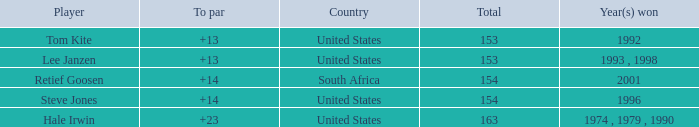In what year did the United States win To par greater than 14 1974 , 1979 , 1990. 